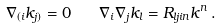Convert formula to latex. <formula><loc_0><loc_0><loc_500><loc_500>\nabla _ { ( i } k _ { j ) } = 0 \quad \nabla _ { i } \nabla _ { j } k _ { l } = R _ { l j i n } k ^ { n } \, .</formula> 